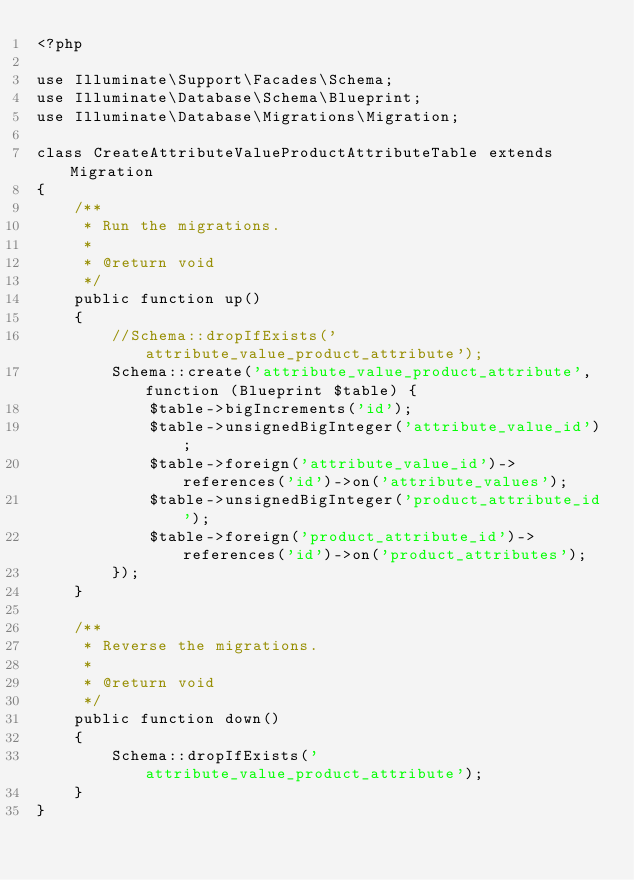<code> <loc_0><loc_0><loc_500><loc_500><_PHP_><?php

use Illuminate\Support\Facades\Schema;
use Illuminate\Database\Schema\Blueprint;
use Illuminate\Database\Migrations\Migration;

class CreateAttributeValueProductAttributeTable extends Migration
{
    /**
     * Run the migrations.
     *
     * @return void
     */
    public function up()
    {
        //Schema::dropIfExists('attribute_value_product_attribute');
        Schema::create('attribute_value_product_attribute', function (Blueprint $table) {
            $table->bigIncrements('id');
            $table->unsignedBigInteger('attribute_value_id');
            $table->foreign('attribute_value_id')->references('id')->on('attribute_values');
            $table->unsignedBigInteger('product_attribute_id');
            $table->foreign('product_attribute_id')->references('id')->on('product_attributes');
        });
    }

    /**
     * Reverse the migrations.
     *
     * @return void
     */
    public function down()
    {
        Schema::dropIfExists('attribute_value_product_attribute');
    }
}
</code> 